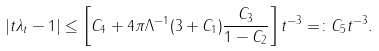<formula> <loc_0><loc_0><loc_500><loc_500>| t \lambda _ { t } - 1 | \leq \left [ C _ { 4 } + 4 \pi \Lambda ^ { - 1 } ( 3 + C _ { 1 } ) \frac { C _ { 3 } } { 1 - C _ { 2 } } \right ] t ^ { - 3 } = \colon C _ { 5 } t ^ { - 3 } .</formula> 